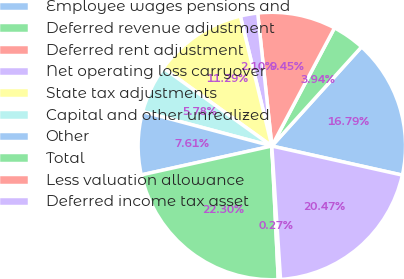Convert chart. <chart><loc_0><loc_0><loc_500><loc_500><pie_chart><fcel>Employee wages pensions and<fcel>Deferred revenue adjustment<fcel>Deferred rent adjustment<fcel>Net operating loss carryover<fcel>State tax adjustments<fcel>Capital and other unrealized<fcel>Other<fcel>Total<fcel>Less valuation allowance<fcel>Deferred income tax asset<nl><fcel>16.79%<fcel>3.94%<fcel>9.45%<fcel>2.1%<fcel>11.29%<fcel>5.78%<fcel>7.61%<fcel>22.3%<fcel>0.27%<fcel>20.47%<nl></chart> 